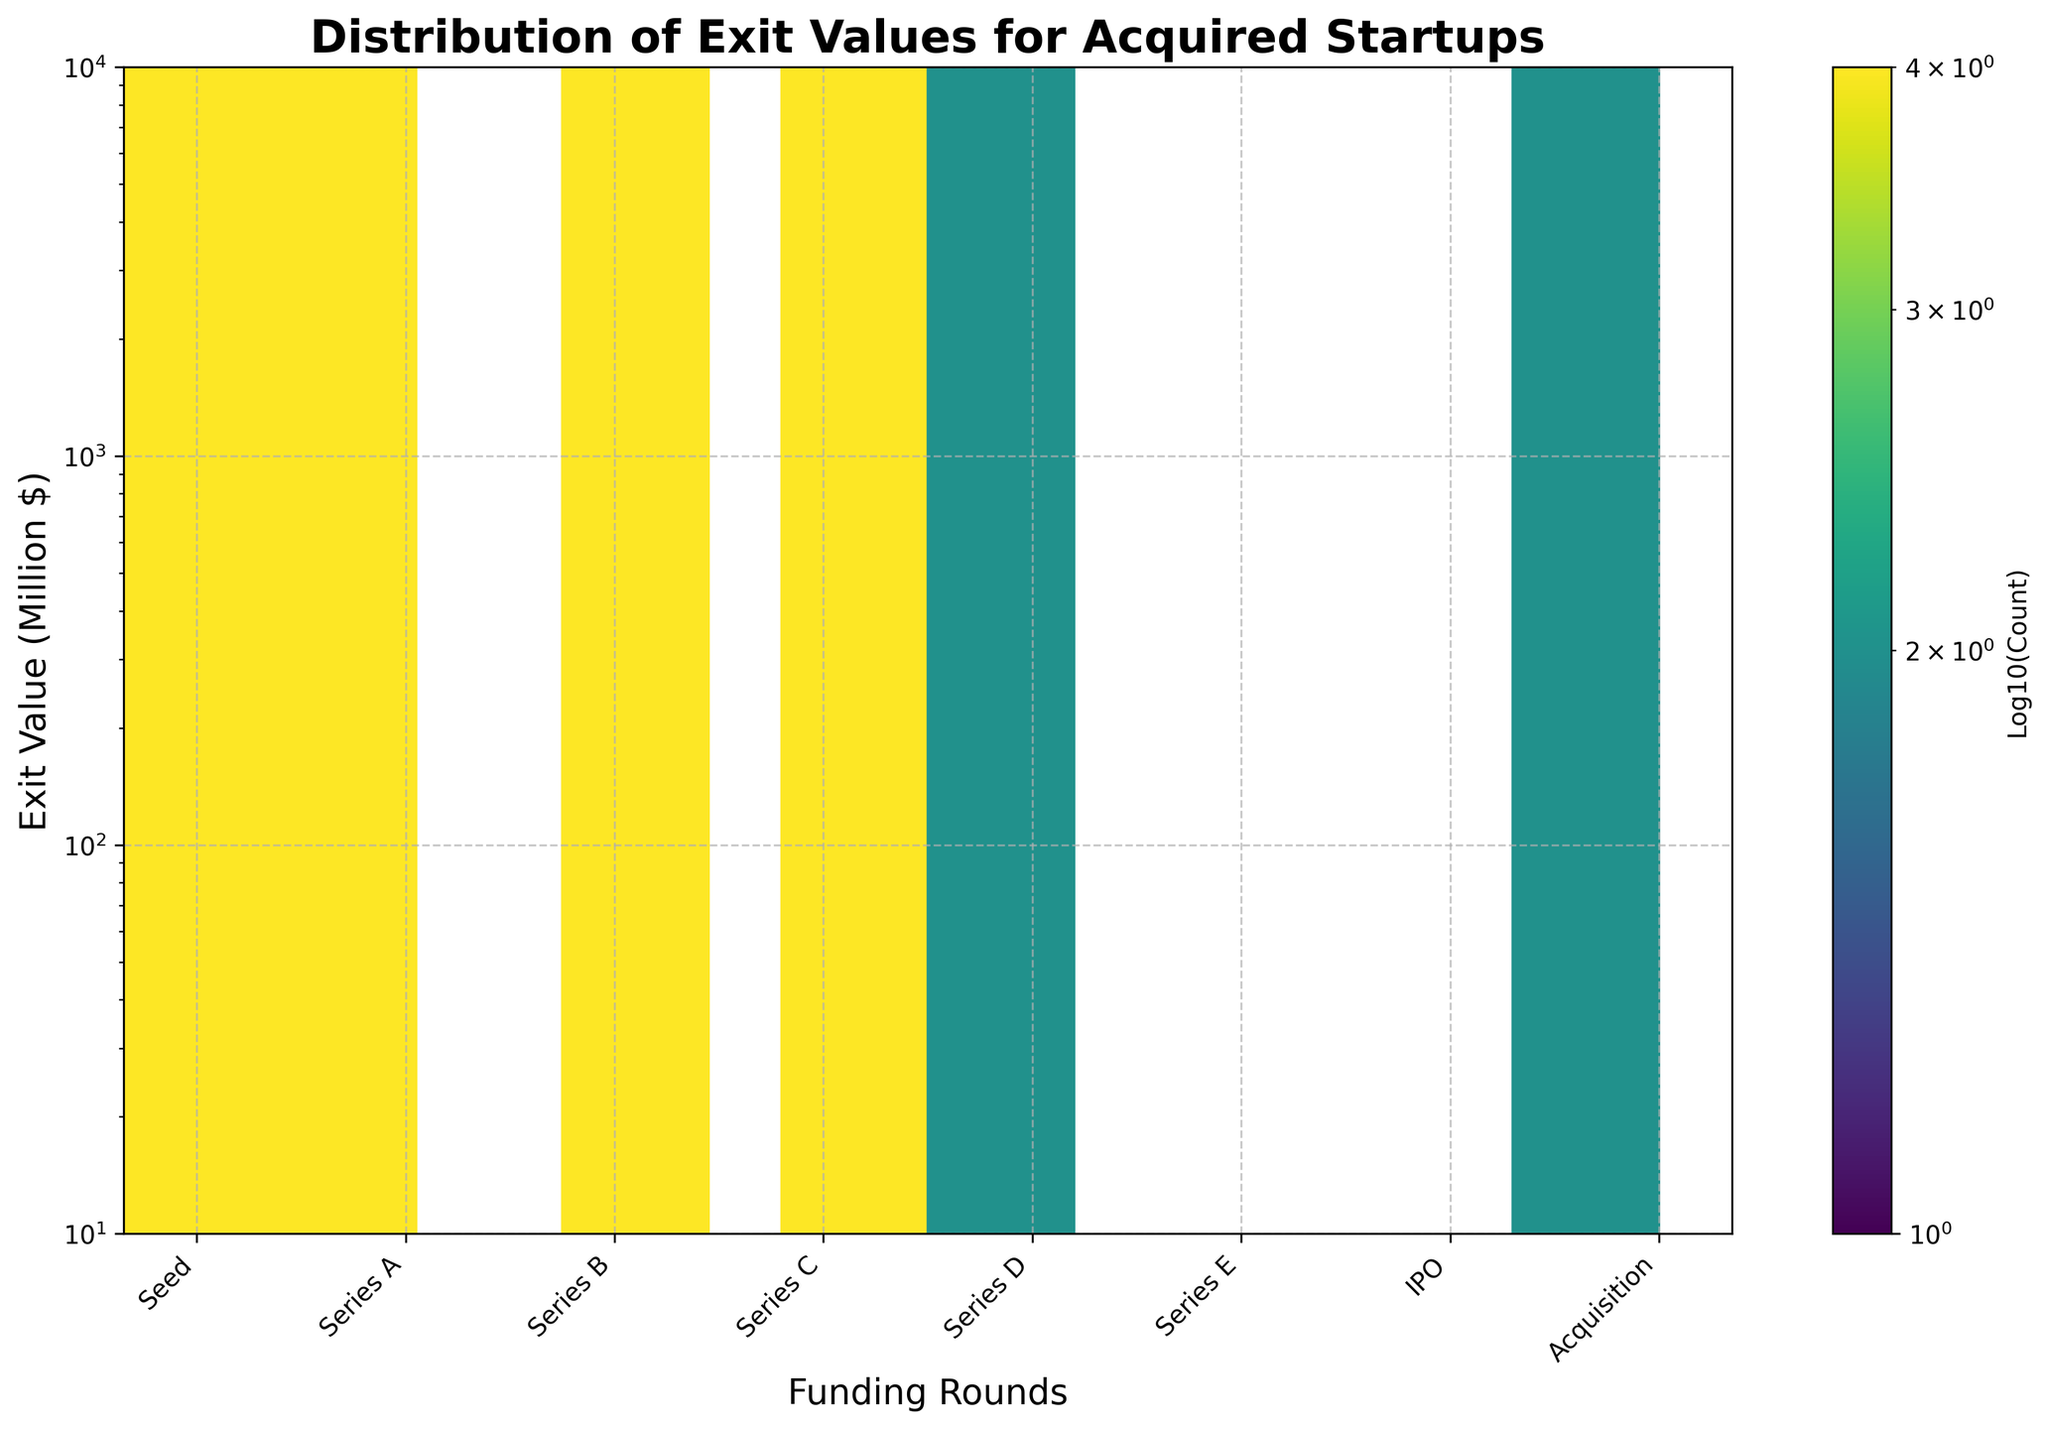What is the title of the figure? The title can be found at the top of the figure. It reads "Distribution of Exit Values for Acquired Startups".
Answer: Distribution of Exit Values for Acquired Startups What axis represents the funding rounds, and what are the labels? The x-axis represents the funding rounds, and the labels from left to right are Seed, Series A, Series B, Series C, Series D, Series E, IPO, and Acquisition.
Answer: x-axis with labels Seed, Series A, Series B, Series C, Series D, Series E, IPO, and Acquisition Which axis is on a logarithmic scale? The y-axis, representing Exit Value in millions of dollars, is on a logarithmic scale. This is indicated by the log scale of numbers ranging from 10 to 10000.
Answer: y-axis Which funding round has the highest exit values in the dataset? By looking at the hexbin plot, the IPO funding round displays the highest exit values, with some points reaching as high as $7000 million.
Answer: IPO In which funding round do clusters appear densest? The densest clusters, indicated by the darkest hexagons, appear in the Seed and Series A rounds. These zones have more aggregated data points.
Answer: Seed and Series A Do exit values generally increase with the number of funding rounds? Yes, as seen from the hexbin plot, exit values tend to increase with more advanced funding rounds, moving from Seed to IPO. The highest exit values are present in Series D, E, and IPO rounds.
Answer: Yes Which funding rounds exhibit the widest range of exit values? Series D and IPO rounds show the widest range of exit values. In Series D, values range from around $900 million to $1500 million, and in IPO, they range from $4500 million up to $7000 million.
Answer: Series D and IPO For which funding rounds do exit values exceed $2000 million? According to the plot, exit values exceed $2000 million in Series D, Series E, and IPO funding rounds.
Answer: Series D, Series E, and IPO Is there any funding round that does not show a dense cluster around the lower exit values? Yes, the IPO round does not show a dense cluster around lower exit values; it primarily shows higher exit values ranging above $4500 million.
Answer: IPO How do the exit values for Acquisition compare to those of Series D? The exit values for Acquisitions are generally lower, ranging from $750 million to $1200 million, whereas Series D exit values range significantly higher, from $900 million to $1500 million.
Answer: Acquisition values are lower than Series D values 